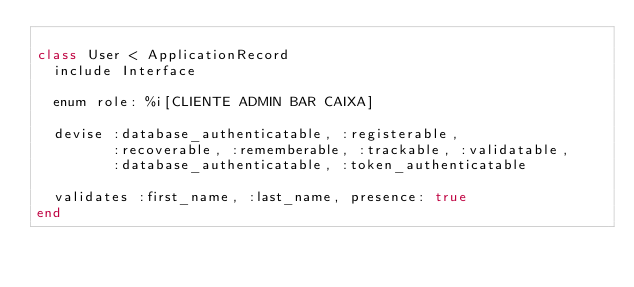Convert code to text. <code><loc_0><loc_0><loc_500><loc_500><_Ruby_>
class User < ApplicationRecord
  include Interface

  enum role: %i[CLIENTE ADMIN BAR CAIXA]
  
  devise :database_authenticatable, :registerable,
         :recoverable, :rememberable, :trackable, :validatable,
         :database_authenticatable, :token_authenticatable

  validates :first_name, :last_name, presence: true
end
</code> 